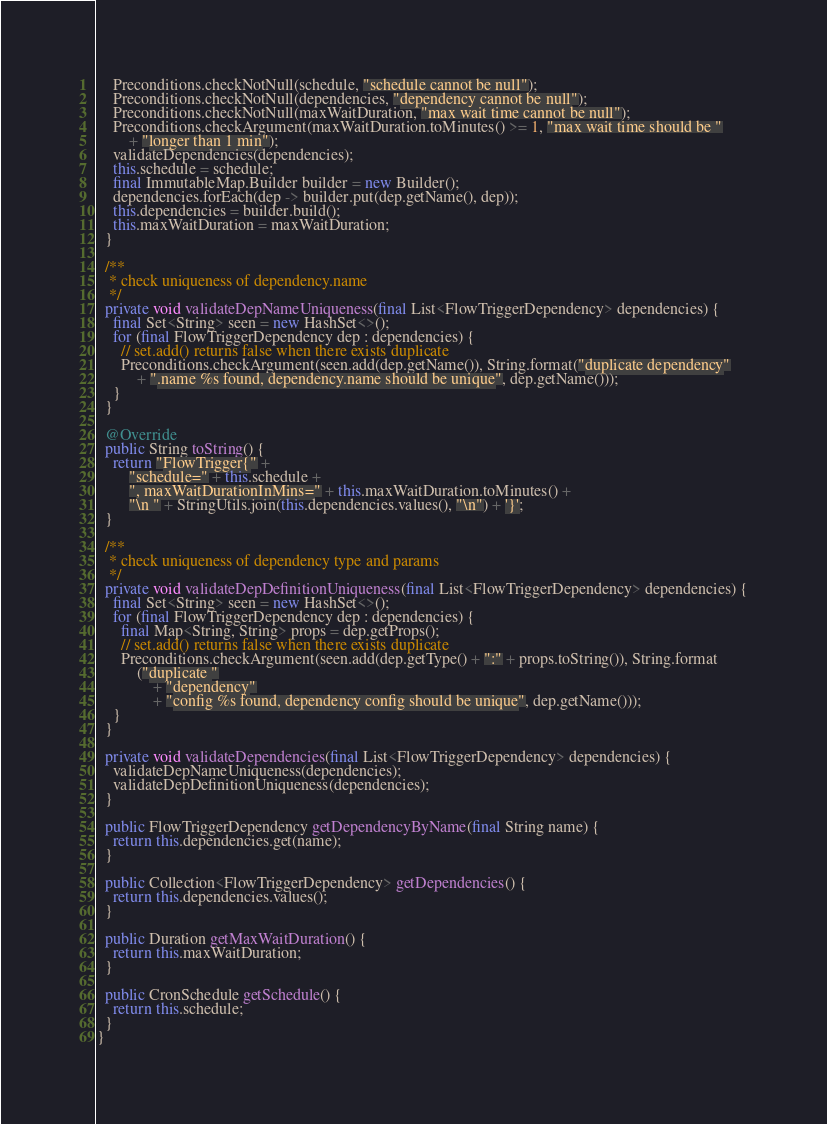Convert code to text. <code><loc_0><loc_0><loc_500><loc_500><_Java_>    Preconditions.checkNotNull(schedule, "schedule cannot be null");
    Preconditions.checkNotNull(dependencies, "dependency cannot be null");
    Preconditions.checkNotNull(maxWaitDuration, "max wait time cannot be null");
    Preconditions.checkArgument(maxWaitDuration.toMinutes() >= 1, "max wait time should be "
        + "longer than 1 min");
    validateDependencies(dependencies);
    this.schedule = schedule;
    final ImmutableMap.Builder builder = new Builder();
    dependencies.forEach(dep -> builder.put(dep.getName(), dep));
    this.dependencies = builder.build();
    this.maxWaitDuration = maxWaitDuration;
  }

  /**
   * check uniqueness of dependency.name
   */
  private void validateDepNameUniqueness(final List<FlowTriggerDependency> dependencies) {
    final Set<String> seen = new HashSet<>();
    for (final FlowTriggerDependency dep : dependencies) {
      // set.add() returns false when there exists duplicate
      Preconditions.checkArgument(seen.add(dep.getName()), String.format("duplicate dependency"
          + ".name %s found, dependency.name should be unique", dep.getName()));
    }
  }

  @Override
  public String toString() {
    return "FlowTrigger{" +
        "schedule=" + this.schedule +
        ", maxWaitDurationInMins=" + this.maxWaitDuration.toMinutes() +
        "\n " + StringUtils.join(this.dependencies.values(), "\n") + '}';
  }

  /**
   * check uniqueness of dependency type and params
   */
  private void validateDepDefinitionUniqueness(final List<FlowTriggerDependency> dependencies) {
    final Set<String> seen = new HashSet<>();
    for (final FlowTriggerDependency dep : dependencies) {
      final Map<String, String> props = dep.getProps();
      // set.add() returns false when there exists duplicate
      Preconditions.checkArgument(seen.add(dep.getType() + ":" + props.toString()), String.format
          ("duplicate "
              + "dependency"
              + "config %s found, dependency config should be unique", dep.getName()));
    }
  }

  private void validateDependencies(final List<FlowTriggerDependency> dependencies) {
    validateDepNameUniqueness(dependencies);
    validateDepDefinitionUniqueness(dependencies);
  }

  public FlowTriggerDependency getDependencyByName(final String name) {
    return this.dependencies.get(name);
  }

  public Collection<FlowTriggerDependency> getDependencies() {
    return this.dependencies.values();
  }

  public Duration getMaxWaitDuration() {
    return this.maxWaitDuration;
  }

  public CronSchedule getSchedule() {
    return this.schedule;
  }
}
</code> 